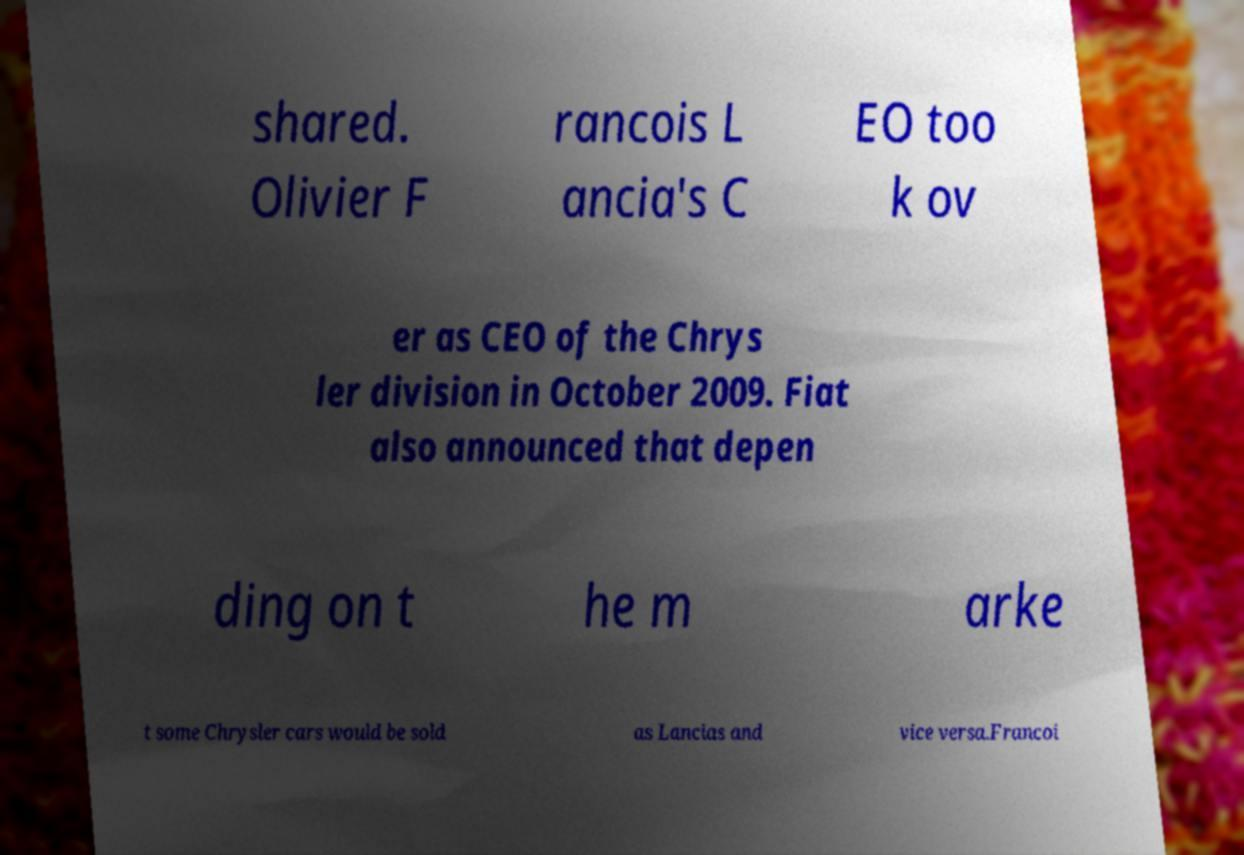Could you extract and type out the text from this image? shared. Olivier F rancois L ancia's C EO too k ov er as CEO of the Chrys ler division in October 2009. Fiat also announced that depen ding on t he m arke t some Chrysler cars would be sold as Lancias and vice versa.Francoi 